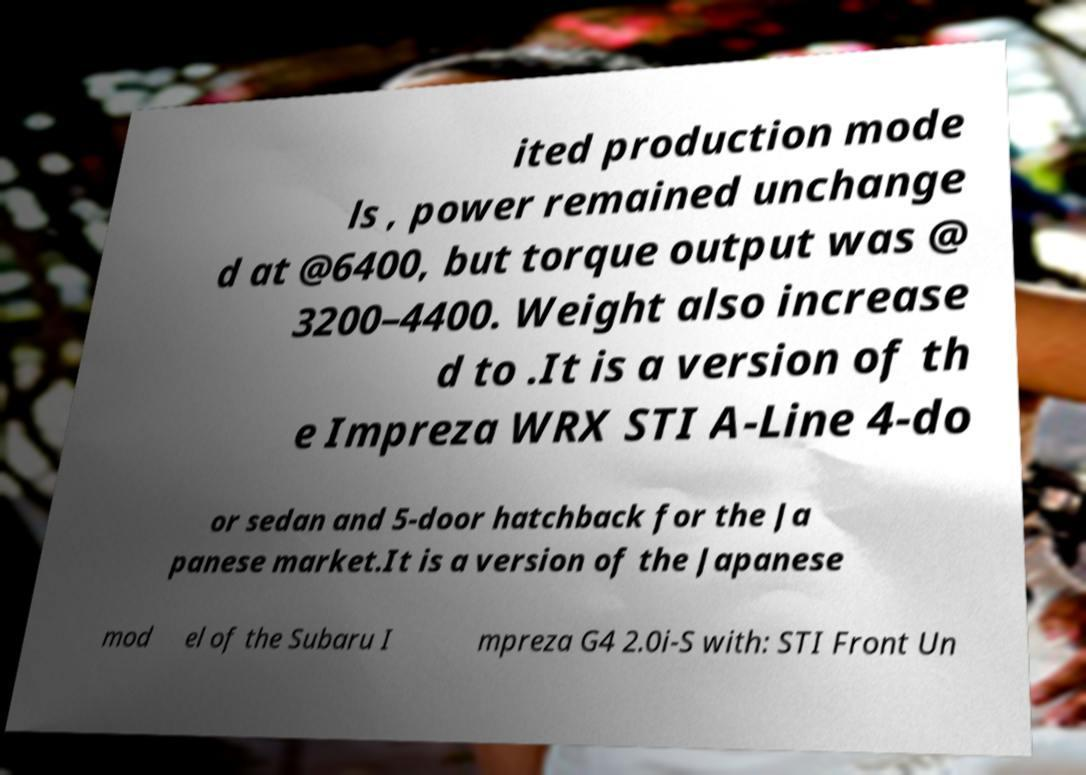There's text embedded in this image that I need extracted. Can you transcribe it verbatim? ited production mode ls , power remained unchange d at @6400, but torque output was @ 3200–4400. Weight also increase d to .It is a version of th e Impreza WRX STI A-Line 4-do or sedan and 5-door hatchback for the Ja panese market.It is a version of the Japanese mod el of the Subaru I mpreza G4 2.0i-S with: STI Front Un 